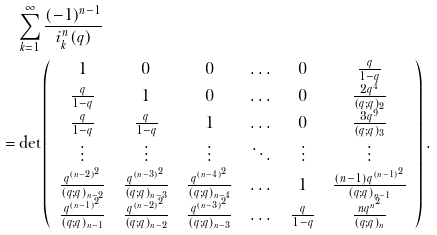Convert formula to latex. <formula><loc_0><loc_0><loc_500><loc_500>& \sum _ { k = 1 } ^ { \infty } \frac { ( - 1 ) ^ { n - 1 } } { i _ { k } ^ { n } ( q ) } \\ = & \det \left ( \begin{array} { c c c c c c } 1 & 0 & 0 & \dots & 0 & \frac { q } { 1 - q } \\ \frac { q } { 1 - q } & 1 & 0 & \dots & 0 & \frac { 2 q ^ { 4 } } { ( q ; q ) _ { 2 } } \\ \frac { q } { 1 - q } & \frac { q } { 1 - q } & 1 & \dots & 0 & \frac { 3 q ^ { 9 } } { ( q ; q ) _ { 3 } } \\ \vdots & \vdots & \vdots & \ddots & \vdots & \vdots \\ \frac { q ^ { ( n - 2 ) ^ { 2 } } } { ( q ; q ) _ { n - 2 } } & \frac { q ^ { ( n - 3 ) ^ { 2 } } } { ( q ; q ) _ { n - 3 } } & \frac { q ^ { ( n - 4 ) ^ { 2 } } } { ( q ; q ) _ { n - 4 } } & \dots & 1 & \frac { ( n - 1 ) q ^ { ( n - 1 ) ^ { 2 } } } { ( q ; q ) _ { n - 1 } } \\ \frac { q ^ { ( n - 1 ) ^ { 2 } } } { ( q ; q ) _ { n - 1 } } & \frac { q ^ { ( n - 2 ) ^ { 2 } } } { ( q ; q ) _ { n - 2 } } & \frac { q ^ { ( n - 3 ) ^ { 2 } } } { ( q ; q ) _ { n - 3 } } & \dots & \frac { q } { 1 - q } & \frac { n q ^ { n ^ { 2 } } } { ( q ; q ) _ { n } } \end{array} \right ) .</formula> 